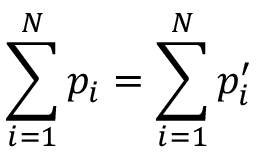<formula> <loc_0><loc_0><loc_500><loc_500>\sum _ { i = 1 } ^ { N } p _ { i } = \sum _ { i = 1 } ^ { N } p _ { i } ^ { \prime }</formula> 